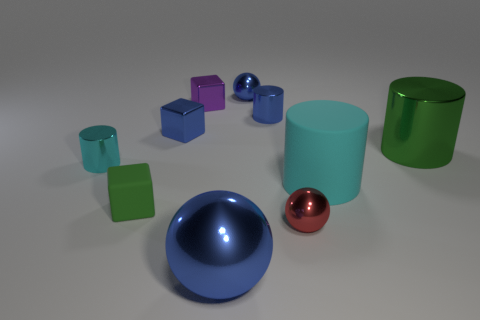What might be the function of these objects if they were part of a larger machine? If these objects were components of a larger machine, the cylinders could serve as pistons or rollers, the spheres might act as bearings or knobs, and the cubes could be used as connectors or weights, each performing a unique mechanical function to enable movement or support structure. 